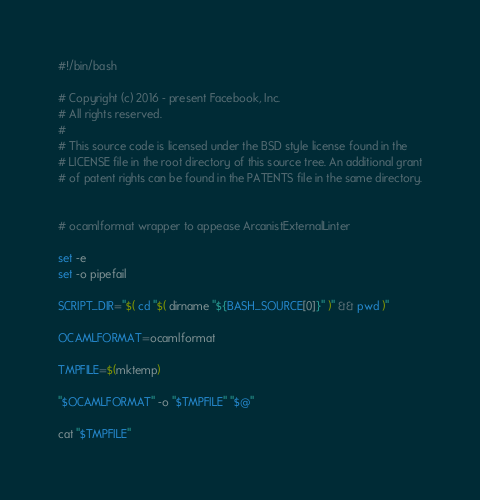Convert code to text. <code><loc_0><loc_0><loc_500><loc_500><_Bash_>#!/bin/bash

# Copyright (c) 2016 - present Facebook, Inc.
# All rights reserved.
#
# This source code is licensed under the BSD style license found in the
# LICENSE file in the root directory of this source tree. An additional grant
# of patent rights can be found in the PATENTS file in the same directory.


# ocamlformat wrapper to appease ArcanistExternalLinter

set -e
set -o pipefail

SCRIPT_DIR="$( cd "$( dirname "${BASH_SOURCE[0]}" )" && pwd )"

OCAMLFORMAT=ocamlformat

TMPFILE=$(mktemp)

"$OCAMLFORMAT" -o "$TMPFILE" "$@"

cat "$TMPFILE"
</code> 